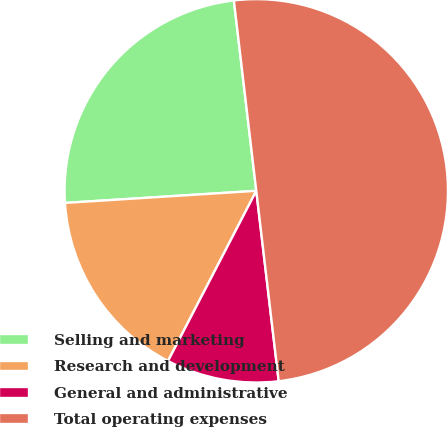Convert chart to OTSL. <chart><loc_0><loc_0><loc_500><loc_500><pie_chart><fcel>Selling and marketing<fcel>Research and development<fcel>General and administrative<fcel>Total operating expenses<nl><fcel>24.14%<fcel>16.38%<fcel>9.48%<fcel>50.0%<nl></chart> 